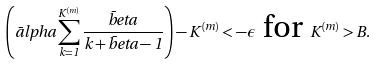Convert formula to latex. <formula><loc_0><loc_0><loc_500><loc_500>\left ( \bar { a } l p h a \sum ^ { K ^ { ( m ) } } _ { k = 1 } \frac { \bar { b } e t a } { k + \bar { b } e t a - 1 } \right ) - K ^ { ( m ) } < - \epsilon \text { for } K ^ { ( m ) } > B .</formula> 